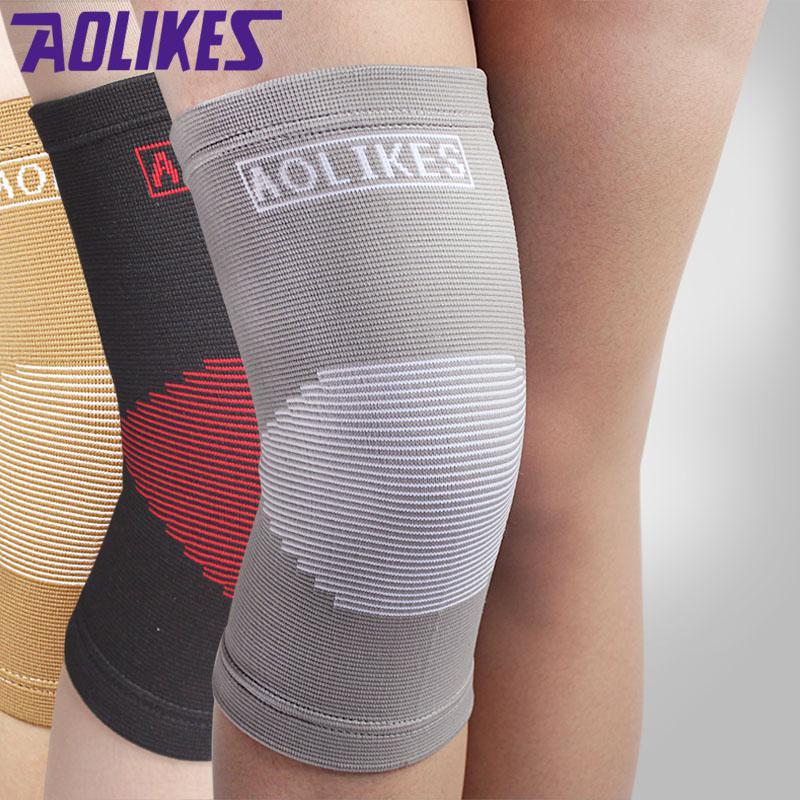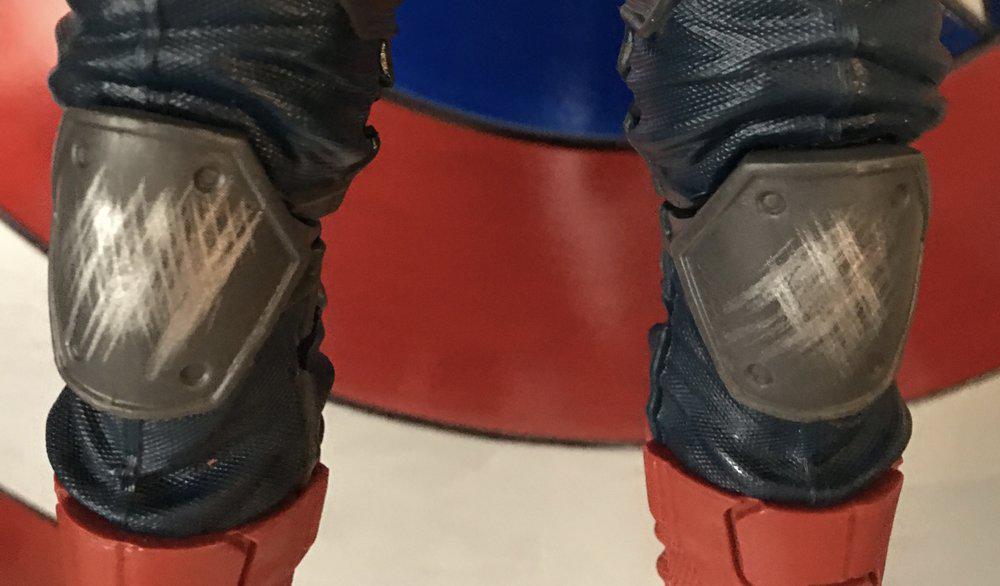The first image is the image on the left, the second image is the image on the right. Assess this claim about the two images: "An image shows legs only wearing non-bulky knee wraps, and shows three color options.". Correct or not? Answer yes or no. Yes. The first image is the image on the left, the second image is the image on the right. Given the left and right images, does the statement "At least one of the images does not contain the legs of a human." hold true? Answer yes or no. No. The first image is the image on the left, the second image is the image on the right. For the images shown, is this caption "All images show legs wearing kneepads." true? Answer yes or no. Yes. The first image is the image on the left, the second image is the image on the right. Considering the images on both sides, is "One of the images appears to contain at least three female knees." valid? Answer yes or no. Yes. 